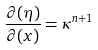Convert formula to latex. <formula><loc_0><loc_0><loc_500><loc_500>\frac { \partial ( \eta ) } { \partial ( x ) } = \kappa ^ { n + 1 }</formula> 